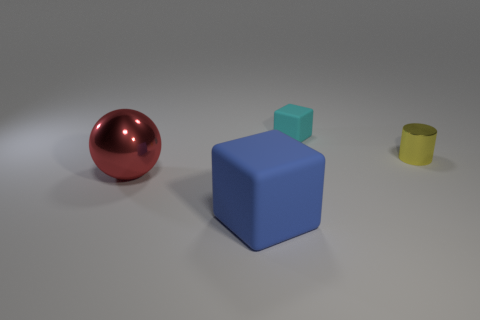The cube that is in front of the metal object behind the big metallic object is made of what material?
Keep it short and to the point. Rubber. There is another object that is the same shape as the tiny cyan rubber object; what is it made of?
Give a very brief answer. Rubber. Is there a small metal cylinder in front of the big thing behind the cube that is left of the tiny block?
Give a very brief answer. No. How many other objects are the same color as the cylinder?
Offer a very short reply. 0. How many shiny things are left of the small cyan block and behind the large sphere?
Your answer should be very brief. 0. There is a blue object; what shape is it?
Provide a short and direct response. Cube. There is a matte object left of the thing that is behind the shiny object to the right of the tiny rubber block; what color is it?
Provide a short and direct response. Blue. There is a object that is the same size as the yellow metal cylinder; what is its material?
Make the answer very short. Rubber. What number of things are either cubes that are behind the yellow metallic thing or large blue matte objects?
Make the answer very short. 2. Is there a tiny rubber block?
Give a very brief answer. Yes. 